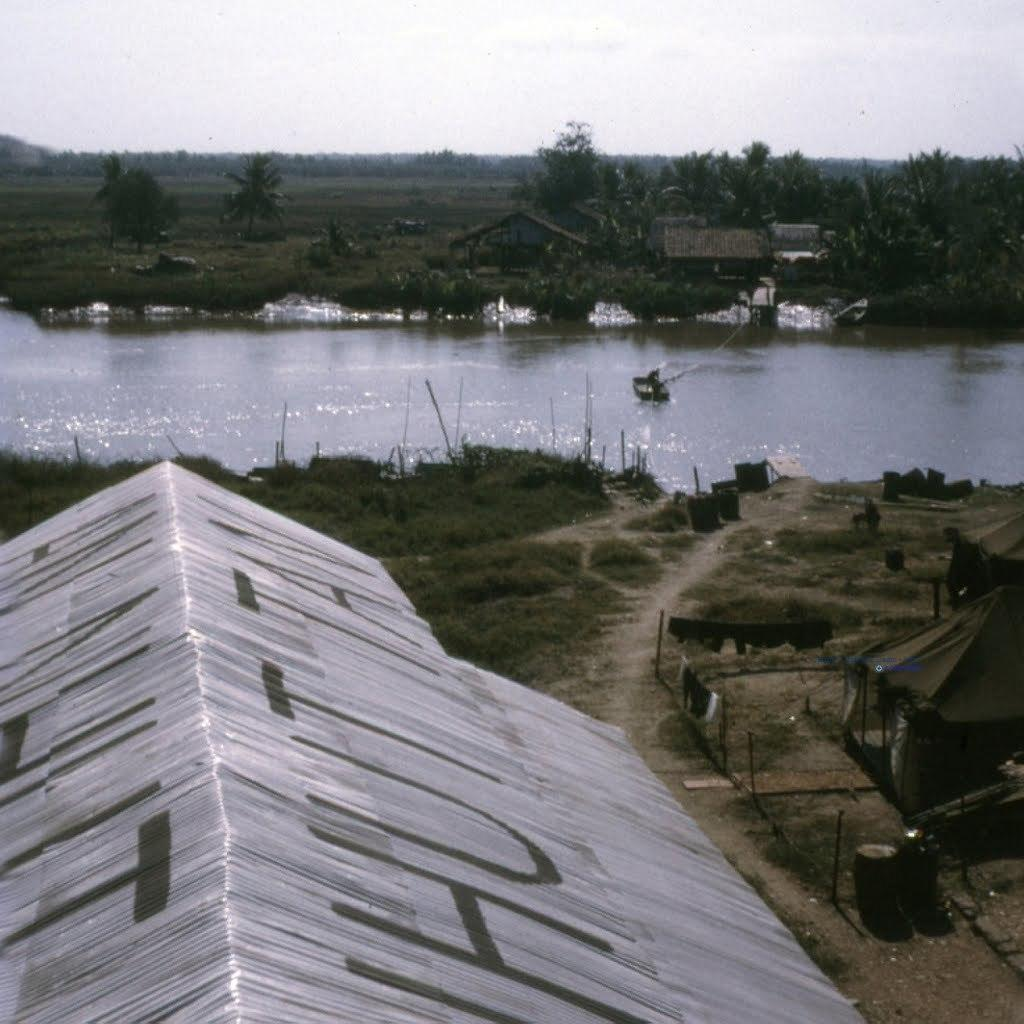What type of outdoor space is shown in the image? The image shows a rooftop. What type of shelter is set up on the rooftop? There is a tent on the rooftop. What can be seen hanging or placed on the rooftop? Clothes are visible in the image. What type of ground surface is present on the rooftop? There is grass on the rooftop. What can be seen in the distance behind the rooftop? Water, trees, and houses are visible in the background of the image. What part of the natural environment is visible in the background? The sky is visible in the background of the image. How many tomatoes are being held by the brothers in the image? There are no tomatoes or brothers present in the image. 